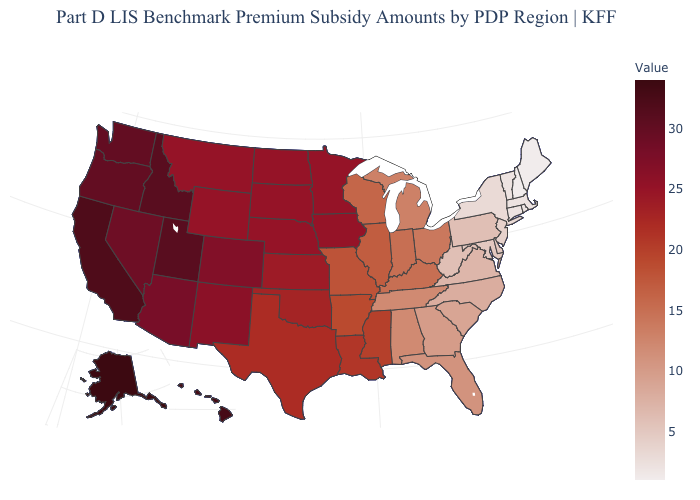Among the states that border Idaho , does Oregon have the lowest value?
Give a very brief answer. No. Does Oklahoma have the highest value in the South?
Give a very brief answer. Yes. Among the states that border New Jersey , which have the highest value?
Answer briefly. Pennsylvania. Does Kansas have a higher value than Arizona?
Concise answer only. No. 